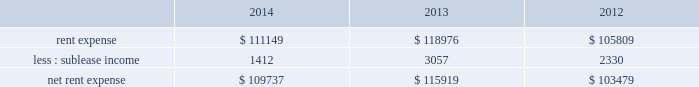Adobe systems incorporated notes to consolidated financial statements ( continued ) note 15 .
Commitments and contingencies lease commitments we lease certain of our facilities and some of our equipment under non-cancellable operating lease arrangements that expire at various dates through 2028 .
We also have one land lease that expires in 2091 .
Rent expense includes base contractual rent and variable costs such as building expenses , utilities , taxes , insurance and equipment rental .
Rent expense and sublease income for these leases for fiscal 2014 , 2013 and 2012 were as follows ( in thousands ) : .
We occupy three office buildings in san jose , california where our corporate headquarters are located .
We reference these office buildings as the almaden tower and the east and west towers .
In august 2014 , we exercised our option to purchase the east and west towers for a total purchase price of $ 143.2 million .
Upon purchase , our investment in the lease receivable of $ 126.8 million was credited against the total purchase price and we were no longer required to maintain a standby letter of credit as stipulated in the east and west towers lease agreement .
We capitalized the east and west towers as property and equipment on our consolidated balance sheets at $ 144.1 million , the lesser of cost or fair value , which represented the total purchase price plus other direct costs associated with the purchase .
See note 6 for discussion of our east and west towers purchase .
The lease agreement for the almaden tower is effective through march 2017 .
We are the investors in the lease receivable related to the almaden tower lease in the amount of $ 80.4 million , which is recorded as investment in lease receivable on our consolidated balance sheets .
As of november 28 , 2014 , the carrying value of the lease receivable related to the almaden tower approximated fair value .
Under the agreement for the almaden tower , we have the option to purchase the building at any time during the lease term for $ 103.6 million .
If we purchase the building , the investment in the lease receivable may be credited against the purchase price .
The residual value guarantee under the almaden tower obligation is $ 89.4 million .
The almaden tower lease is subject to standard covenants including certain financial ratios that are reported to the lessor quarterly .
As of november 28 , 2014 , we were in compliance with all of the covenants .
In the case of a default , the lessor may demand we purchase the building for an amount equal to the lease balance , or require that we remarket or relinquish the building .
If we choose to remarket or are required to do so upon relinquishing the building , we are bound to arrange the sale of the building to an unrelated party and will be required to pay the lessor any shortfall between the net remarketing proceeds and the lease balance , up to the residual value guarantee amount less our investment in lease receivable .
The almaden tower lease qualifies for operating lease accounting treatment and , as such , the building and the related obligation are not included in our consolidated balance sheets .
See note 16 for discussion of our capital lease obligation .
Unconditional purchase obligations our purchase obligations consist of agreements to purchase goods and services entered into in the ordinary course of business. .
What portion of the rent expense is covered through sublease income in 2014? 
Computations: (1412 / 111149)
Answer: 0.0127. 